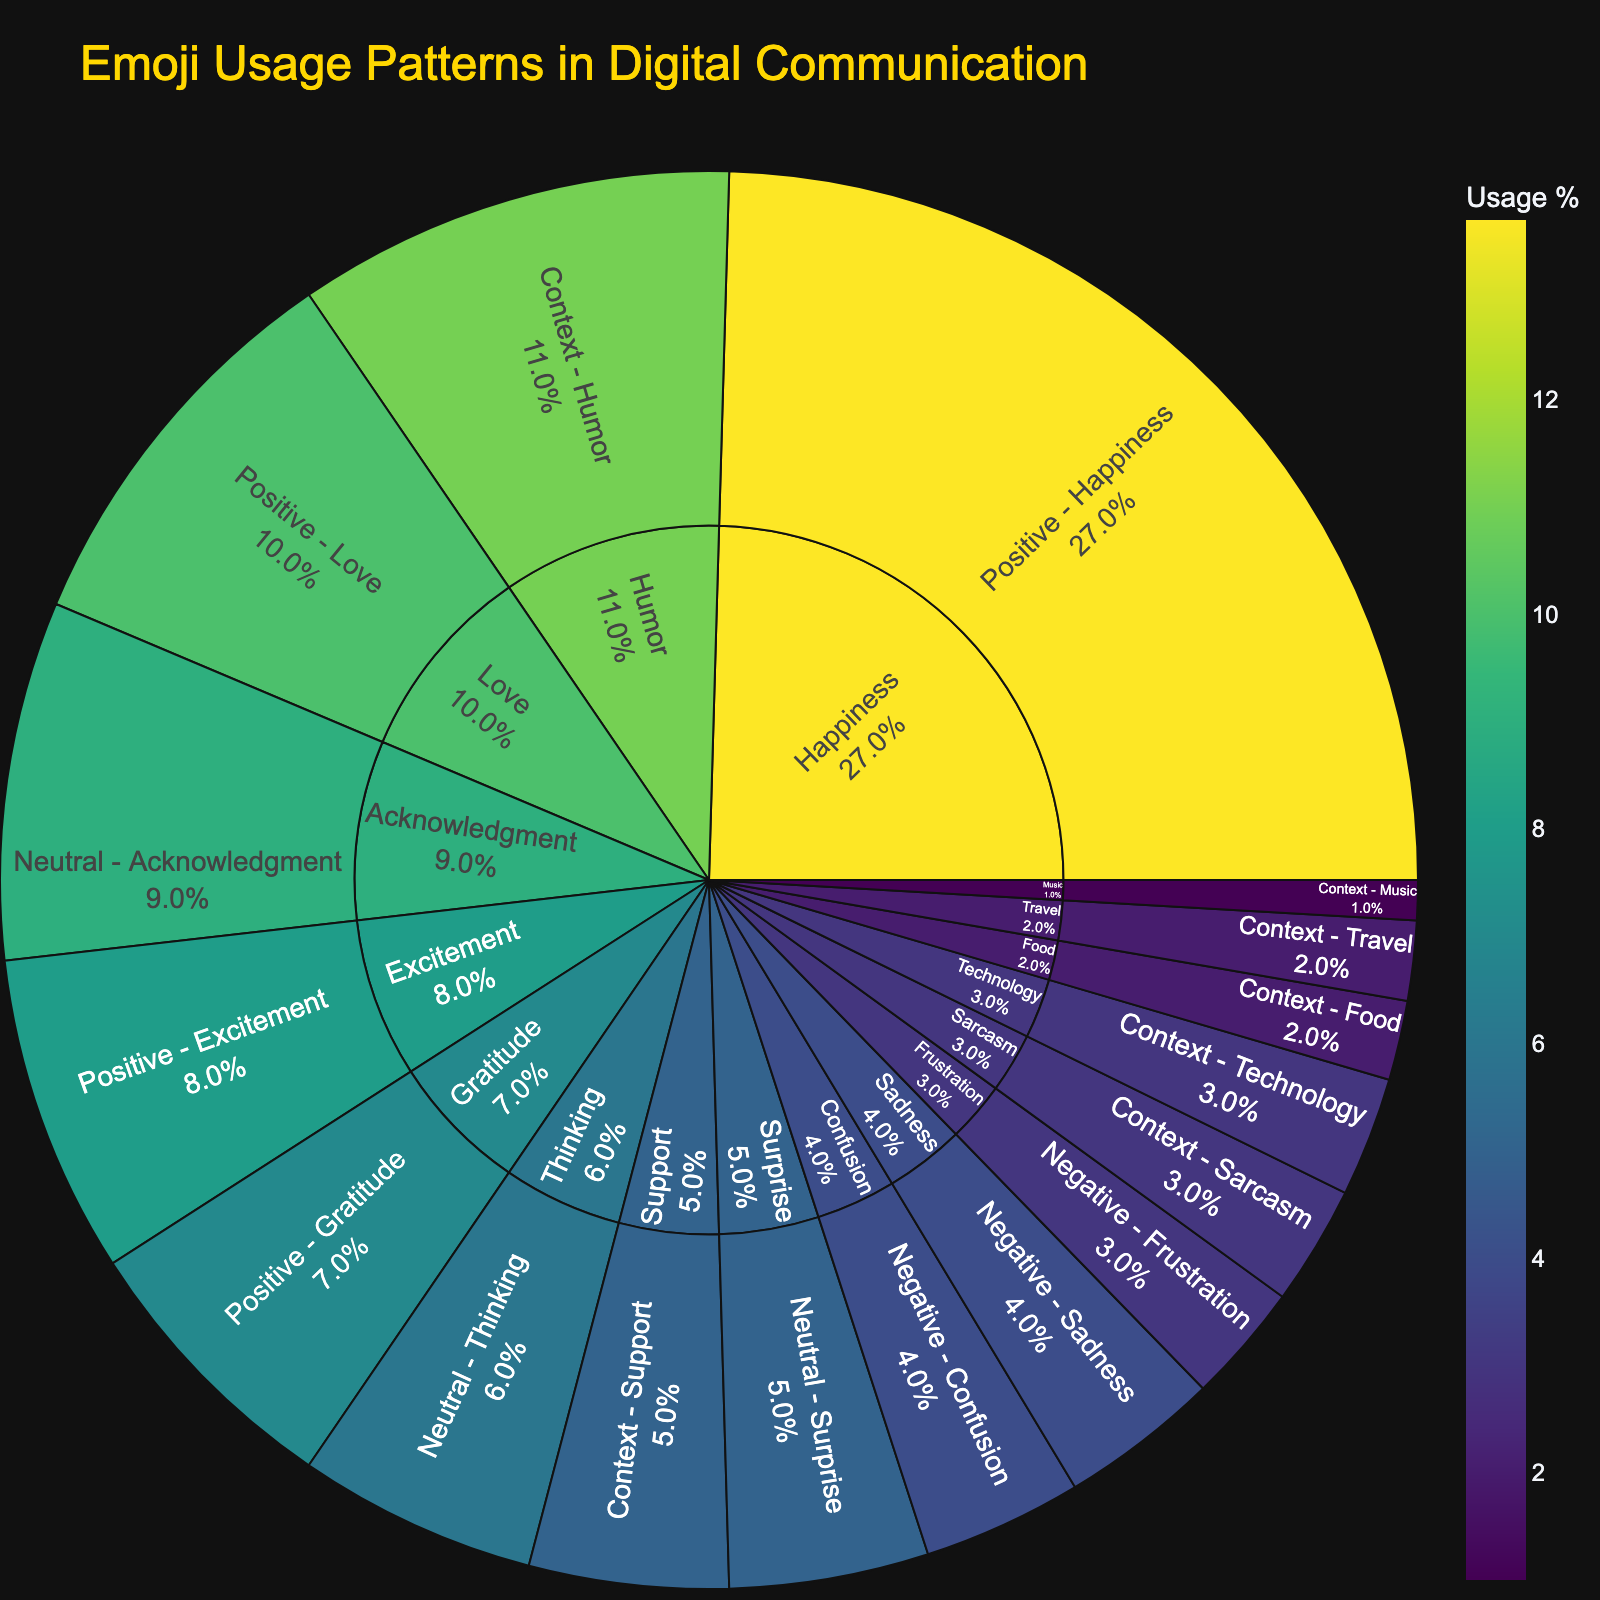What is the most used emoji in the 'Positive' category? To find this, we look at the 'Positive' category and identify which emoji has the highest usage percentage. 😊 has 15%, which is the highest among the Positive category emojis.
Answer: 😊 Which category has the least overall usage percentage, and what is its total percentage? We need to sum up the usage percentages of each category and compare them to determine the least one. The totals are: Positive (52%), Neutral (20%), Negative (11%), Context (27%). The Negative category has the lowest total of 11%.
Answer: Negative, 11% How much more popular is 😂 compared to 🤔? First, note the usage percentages of 😂 (11%) and 🤔 (6%). Then, calculate the difference: 11% - 6% = 5%.
Answer: 5% What is the average usage percentage of emojis in the 'Context' category? Sum the usage percentages for the Context category: (11+3+5+3+2+2+1) = 27%. Then, divide by the number of emojis (7): 27% / 7 ≈ 3.86%.
Answer: 3.86% How does the usage of 😢 compare to 😕? Both emojis are in the Negative category. 😢 has 4% and 😕 also has 4%. Since the percentages are the same, their usage is equal.
Answer: Equal Which category has the highest number of subcategories, and how many does it have? We observe the main categories: Positive, Neutral, Negative, and Context. The Context category appears to have the most subcategories (Humor, Sarcasm, Support, Technology, Food, Travel, Music), making it seven subcategories.
Answer: Context, 7 What is the total usage percentage of all emojis in the 'Neutral' category? Sum the usage percentages for all Neutral emojis: (9+6+5) = 20%.
Answer: 20% Compare the usage of ❤️ and 😄. Which one is more popular and by how much? ❤️ has a usage percentage of 10%, while 😄 has 12%. Subtract 10% from 12% to find the difference: 12% - 10% = 2%. 😄 is more popular by 2%.
Answer: 2% What is the combined usage percentage of emojis representing happiness? Add the usage percentages of 😊 (15%) and 😄 (12%): 15% + 12% = 27%.
Answer: 27% 